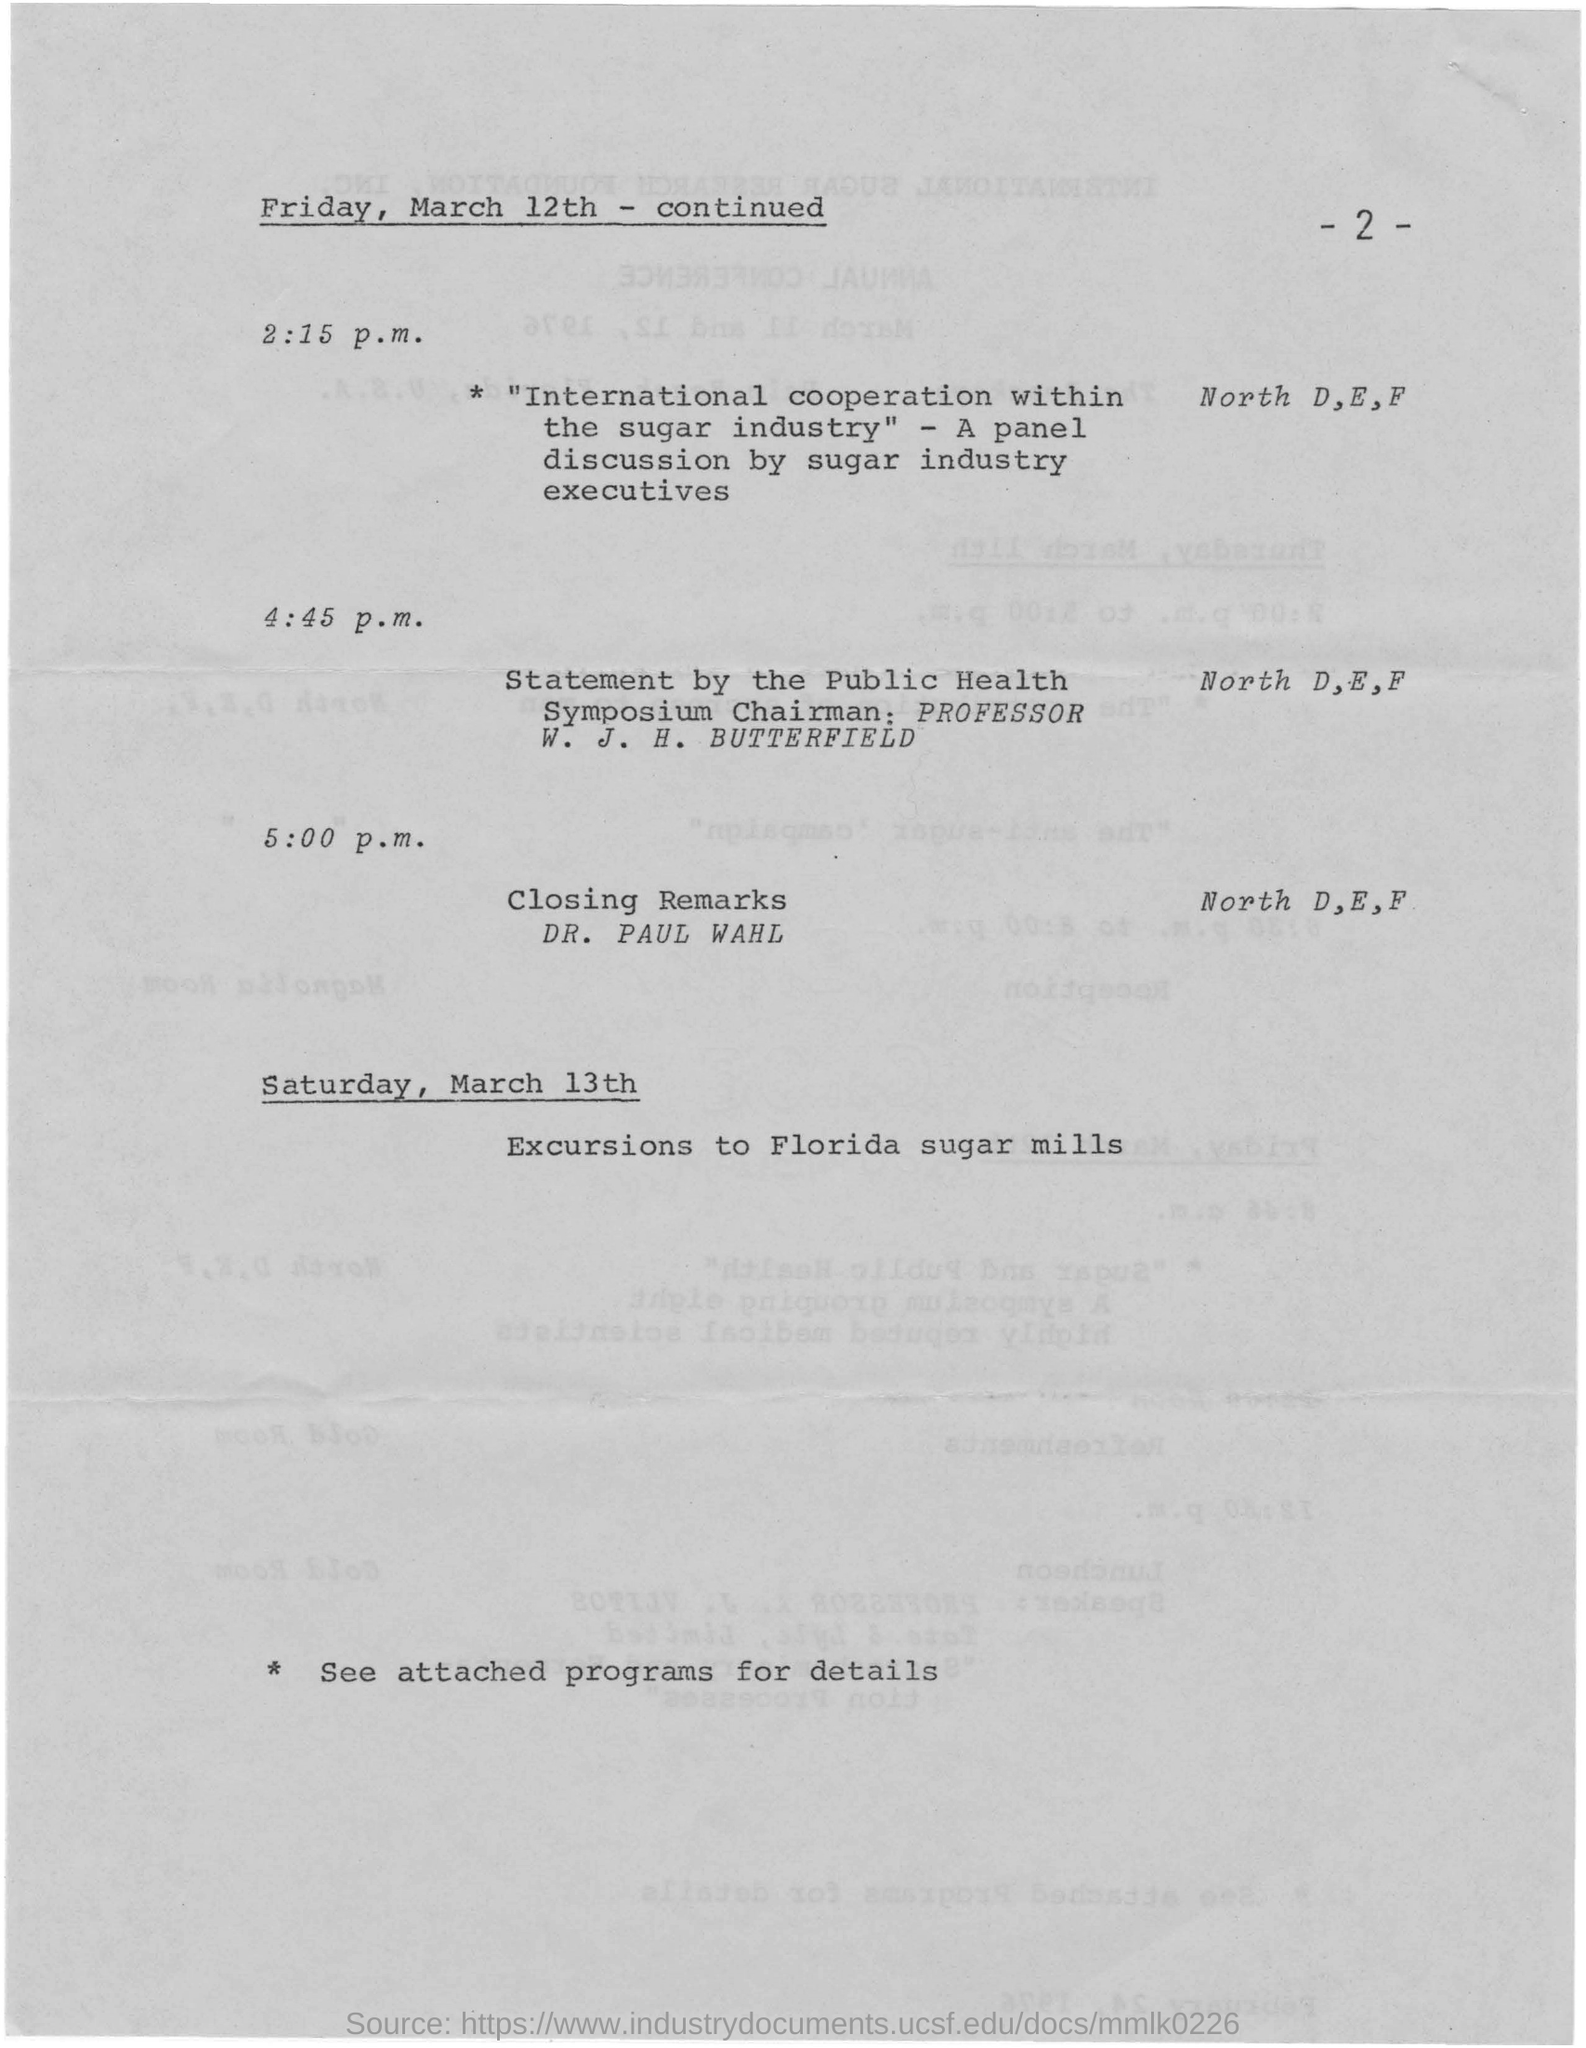Who gave the statement by the Public Health Symposium Chairman ?
Make the answer very short. PROFESSOR W. J. H. BUTTERFIELD. What is the page no mentioned in this document?
Provide a succinct answer. - 2 -. At What time the Closing Remarks?
Your answer should be compact. 5:00 p.m. When the Excursions to Florida sugar mills?
Provide a short and direct response. SATURDAY, MARCH 13TH. 